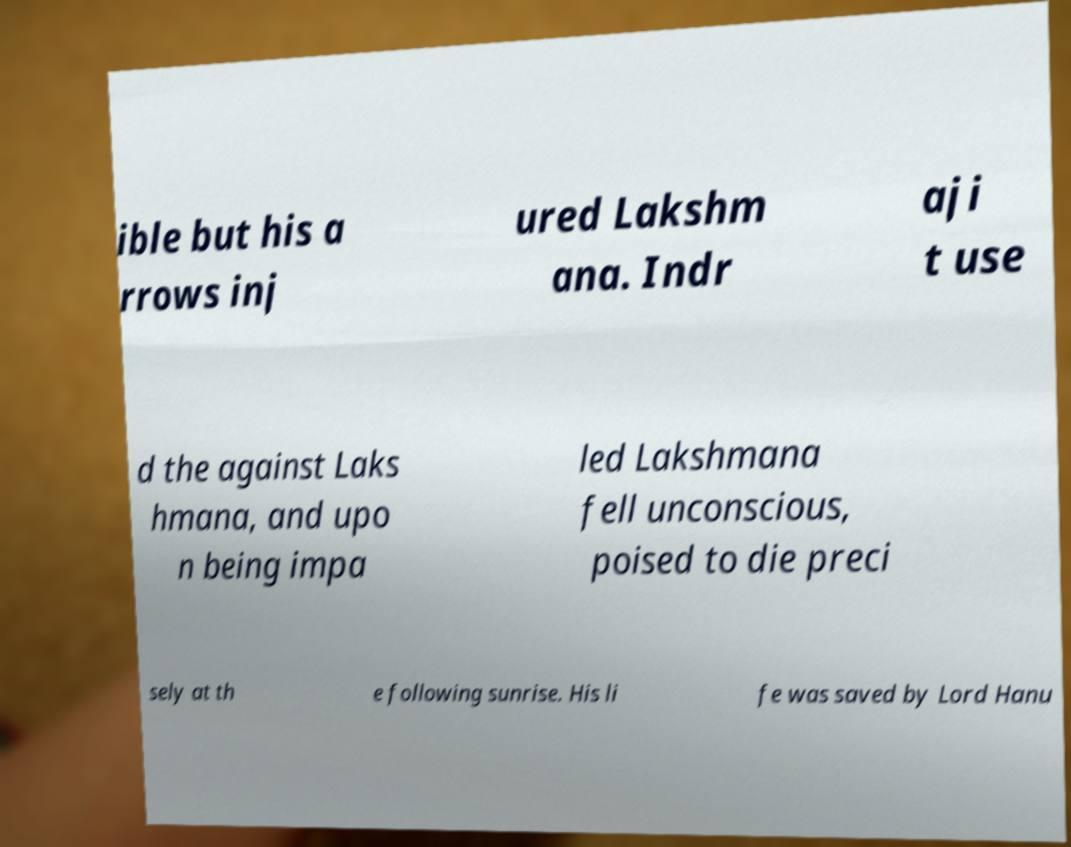Could you assist in decoding the text presented in this image and type it out clearly? ible but his a rrows inj ured Lakshm ana. Indr aji t use d the against Laks hmana, and upo n being impa led Lakshmana fell unconscious, poised to die preci sely at th e following sunrise. His li fe was saved by Lord Hanu 